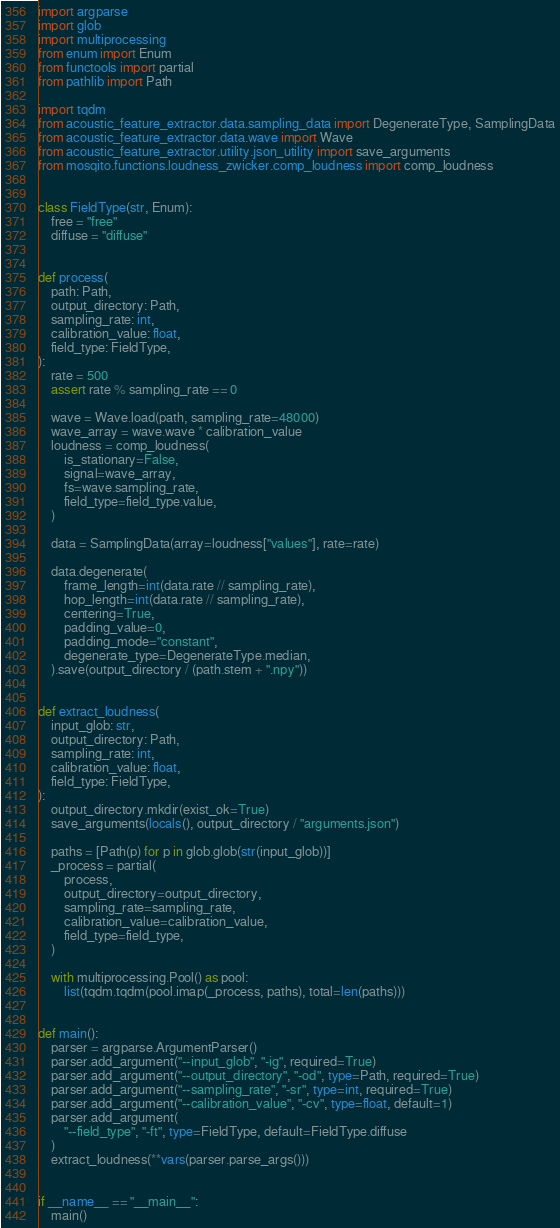<code> <loc_0><loc_0><loc_500><loc_500><_Python_>import argparse
import glob
import multiprocessing
from enum import Enum
from functools import partial
from pathlib import Path

import tqdm
from acoustic_feature_extractor.data.sampling_data import DegenerateType, SamplingData
from acoustic_feature_extractor.data.wave import Wave
from acoustic_feature_extractor.utility.json_utility import save_arguments
from mosqito.functions.loudness_zwicker.comp_loudness import comp_loudness


class FieldType(str, Enum):
    free = "free"
    diffuse = "diffuse"


def process(
    path: Path,
    output_directory: Path,
    sampling_rate: int,
    calibration_value: float,
    field_type: FieldType,
):
    rate = 500
    assert rate % sampling_rate == 0

    wave = Wave.load(path, sampling_rate=48000)
    wave_array = wave.wave * calibration_value
    loudness = comp_loudness(
        is_stationary=False,
        signal=wave_array,
        fs=wave.sampling_rate,
        field_type=field_type.value,
    )

    data = SamplingData(array=loudness["values"], rate=rate)

    data.degenerate(
        frame_length=int(data.rate // sampling_rate),
        hop_length=int(data.rate // sampling_rate),
        centering=True,
        padding_value=0,
        padding_mode="constant",
        degenerate_type=DegenerateType.median,
    ).save(output_directory / (path.stem + ".npy"))


def extract_loudness(
    input_glob: str,
    output_directory: Path,
    sampling_rate: int,
    calibration_value: float,
    field_type: FieldType,
):
    output_directory.mkdir(exist_ok=True)
    save_arguments(locals(), output_directory / "arguments.json")

    paths = [Path(p) for p in glob.glob(str(input_glob))]
    _process = partial(
        process,
        output_directory=output_directory,
        sampling_rate=sampling_rate,
        calibration_value=calibration_value,
        field_type=field_type,
    )

    with multiprocessing.Pool() as pool:
        list(tqdm.tqdm(pool.imap(_process, paths), total=len(paths)))


def main():
    parser = argparse.ArgumentParser()
    parser.add_argument("--input_glob", "-ig", required=True)
    parser.add_argument("--output_directory", "-od", type=Path, required=True)
    parser.add_argument("--sampling_rate", "-sr", type=int, required=True)
    parser.add_argument("--calibration_value", "-cv", type=float, default=1)
    parser.add_argument(
        "--field_type", "-ft", type=FieldType, default=FieldType.diffuse
    )
    extract_loudness(**vars(parser.parse_args()))


if __name__ == "__main__":
    main()
</code> 